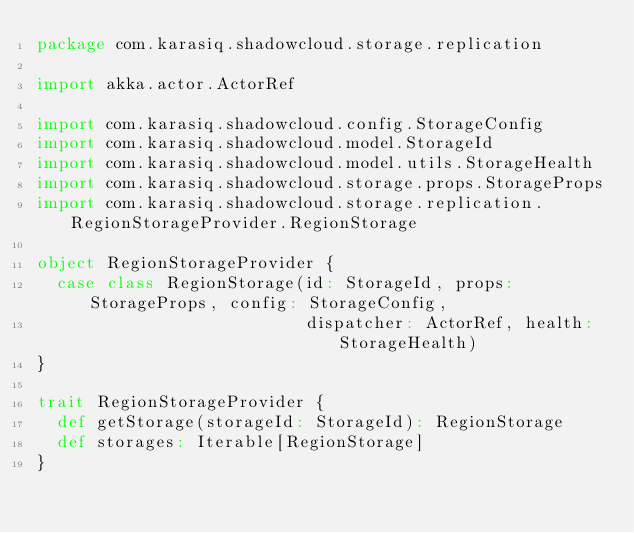Convert code to text. <code><loc_0><loc_0><loc_500><loc_500><_Scala_>package com.karasiq.shadowcloud.storage.replication

import akka.actor.ActorRef

import com.karasiq.shadowcloud.config.StorageConfig
import com.karasiq.shadowcloud.model.StorageId
import com.karasiq.shadowcloud.model.utils.StorageHealth
import com.karasiq.shadowcloud.storage.props.StorageProps
import com.karasiq.shadowcloud.storage.replication.RegionStorageProvider.RegionStorage

object RegionStorageProvider {
  case class RegionStorage(id: StorageId, props: StorageProps, config: StorageConfig,
                           dispatcher: ActorRef, health: StorageHealth)
}

trait RegionStorageProvider {
  def getStorage(storageId: StorageId): RegionStorage
  def storages: Iterable[RegionStorage]
}
</code> 